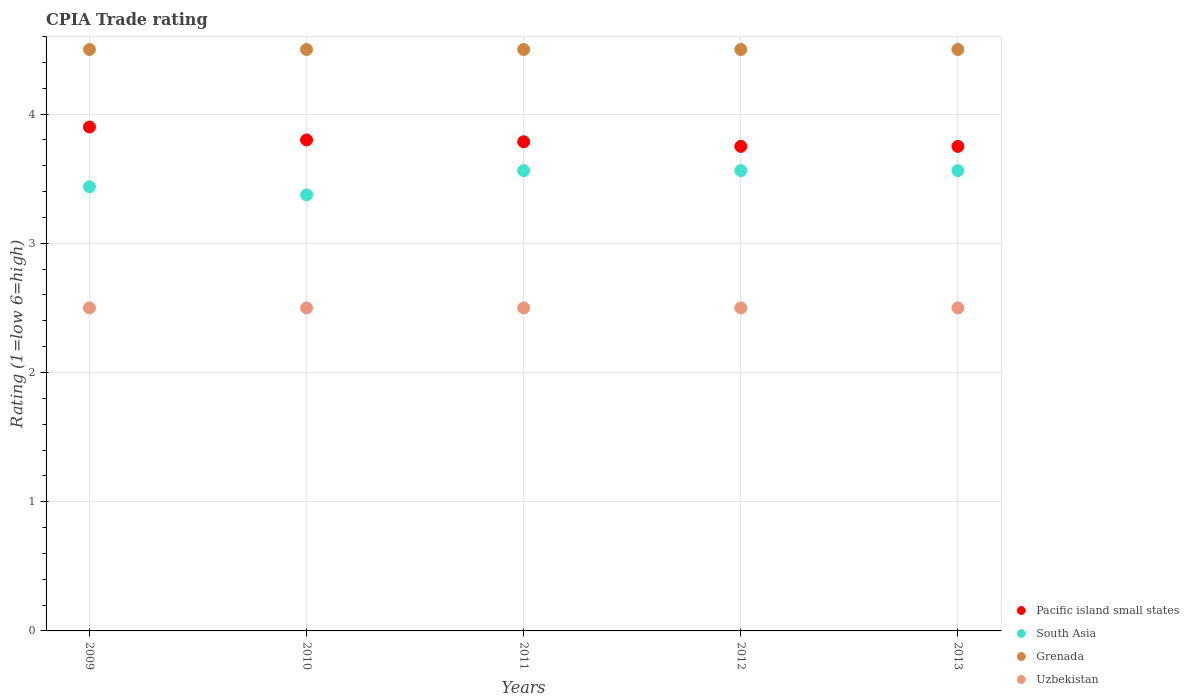Is the number of dotlines equal to the number of legend labels?
Your answer should be compact. Yes. What is the CPIA rating in Uzbekistan in 2011?
Offer a very short reply. 2.5. Across all years, what is the minimum CPIA rating in Pacific island small states?
Offer a terse response. 3.75. In which year was the CPIA rating in Uzbekistan maximum?
Your answer should be compact. 2009. What is the difference between the CPIA rating in Uzbekistan in 2009 and that in 2011?
Provide a short and direct response. 0. What is the difference between the CPIA rating in Pacific island small states in 2013 and the CPIA rating in South Asia in 2012?
Provide a short and direct response. 0.19. What is the average CPIA rating in Grenada per year?
Ensure brevity in your answer.  4.5. In the year 2013, what is the difference between the CPIA rating in Grenada and CPIA rating in South Asia?
Your response must be concise. 0.94. What is the ratio of the CPIA rating in South Asia in 2010 to that in 2011?
Keep it short and to the point. 0.95. Is the CPIA rating in Pacific island small states in 2009 less than that in 2010?
Your answer should be very brief. No. What is the difference between the highest and the second highest CPIA rating in Grenada?
Offer a terse response. 0. Is it the case that in every year, the sum of the CPIA rating in South Asia and CPIA rating in Grenada  is greater than the sum of CPIA rating in Uzbekistan and CPIA rating in Pacific island small states?
Your answer should be compact. Yes. Does the CPIA rating in Pacific island small states monotonically increase over the years?
Provide a succinct answer. No. How many dotlines are there?
Offer a very short reply. 4. How many years are there in the graph?
Ensure brevity in your answer.  5. Does the graph contain grids?
Your answer should be very brief. Yes. Where does the legend appear in the graph?
Provide a short and direct response. Bottom right. How many legend labels are there?
Your response must be concise. 4. What is the title of the graph?
Give a very brief answer. CPIA Trade rating. Does "East Asia (developing only)" appear as one of the legend labels in the graph?
Provide a succinct answer. No. What is the label or title of the X-axis?
Keep it short and to the point. Years. What is the label or title of the Y-axis?
Make the answer very short. Rating (1=low 6=high). What is the Rating (1=low 6=high) of South Asia in 2009?
Ensure brevity in your answer.  3.44. What is the Rating (1=low 6=high) of Grenada in 2009?
Keep it short and to the point. 4.5. What is the Rating (1=low 6=high) of Uzbekistan in 2009?
Make the answer very short. 2.5. What is the Rating (1=low 6=high) of South Asia in 2010?
Keep it short and to the point. 3.38. What is the Rating (1=low 6=high) in Grenada in 2010?
Your response must be concise. 4.5. What is the Rating (1=low 6=high) of Pacific island small states in 2011?
Offer a very short reply. 3.79. What is the Rating (1=low 6=high) in South Asia in 2011?
Provide a succinct answer. 3.56. What is the Rating (1=low 6=high) in Pacific island small states in 2012?
Your answer should be very brief. 3.75. What is the Rating (1=low 6=high) of South Asia in 2012?
Your answer should be very brief. 3.56. What is the Rating (1=low 6=high) of Grenada in 2012?
Your response must be concise. 4.5. What is the Rating (1=low 6=high) of Pacific island small states in 2013?
Your answer should be very brief. 3.75. What is the Rating (1=low 6=high) of South Asia in 2013?
Give a very brief answer. 3.56. What is the Rating (1=low 6=high) in Grenada in 2013?
Make the answer very short. 4.5. Across all years, what is the maximum Rating (1=low 6=high) of Pacific island small states?
Keep it short and to the point. 3.9. Across all years, what is the maximum Rating (1=low 6=high) of South Asia?
Your answer should be compact. 3.56. Across all years, what is the maximum Rating (1=low 6=high) of Uzbekistan?
Offer a very short reply. 2.5. Across all years, what is the minimum Rating (1=low 6=high) of Pacific island small states?
Keep it short and to the point. 3.75. Across all years, what is the minimum Rating (1=low 6=high) of South Asia?
Offer a very short reply. 3.38. Across all years, what is the minimum Rating (1=low 6=high) of Grenada?
Make the answer very short. 4.5. Across all years, what is the minimum Rating (1=low 6=high) in Uzbekistan?
Offer a very short reply. 2.5. What is the total Rating (1=low 6=high) in Pacific island small states in the graph?
Your response must be concise. 18.99. What is the total Rating (1=low 6=high) in South Asia in the graph?
Offer a terse response. 17.5. What is the total Rating (1=low 6=high) of Uzbekistan in the graph?
Provide a short and direct response. 12.5. What is the difference between the Rating (1=low 6=high) in Pacific island small states in 2009 and that in 2010?
Keep it short and to the point. 0.1. What is the difference between the Rating (1=low 6=high) of South Asia in 2009 and that in 2010?
Your response must be concise. 0.06. What is the difference between the Rating (1=low 6=high) in Uzbekistan in 2009 and that in 2010?
Your answer should be compact. 0. What is the difference between the Rating (1=low 6=high) in Pacific island small states in 2009 and that in 2011?
Your answer should be compact. 0.11. What is the difference between the Rating (1=low 6=high) of South Asia in 2009 and that in 2011?
Provide a short and direct response. -0.12. What is the difference between the Rating (1=low 6=high) of South Asia in 2009 and that in 2012?
Your answer should be compact. -0.12. What is the difference between the Rating (1=low 6=high) of Grenada in 2009 and that in 2012?
Offer a very short reply. 0. What is the difference between the Rating (1=low 6=high) in Uzbekistan in 2009 and that in 2012?
Offer a terse response. 0. What is the difference between the Rating (1=low 6=high) in South Asia in 2009 and that in 2013?
Make the answer very short. -0.12. What is the difference between the Rating (1=low 6=high) in Grenada in 2009 and that in 2013?
Your answer should be very brief. 0. What is the difference between the Rating (1=low 6=high) in Pacific island small states in 2010 and that in 2011?
Offer a very short reply. 0.01. What is the difference between the Rating (1=low 6=high) of South Asia in 2010 and that in 2011?
Give a very brief answer. -0.19. What is the difference between the Rating (1=low 6=high) of South Asia in 2010 and that in 2012?
Your answer should be very brief. -0.19. What is the difference between the Rating (1=low 6=high) in South Asia in 2010 and that in 2013?
Provide a succinct answer. -0.19. What is the difference between the Rating (1=low 6=high) in Grenada in 2010 and that in 2013?
Your answer should be very brief. 0. What is the difference between the Rating (1=low 6=high) in Uzbekistan in 2010 and that in 2013?
Give a very brief answer. 0. What is the difference between the Rating (1=low 6=high) of Pacific island small states in 2011 and that in 2012?
Provide a succinct answer. 0.04. What is the difference between the Rating (1=low 6=high) in Pacific island small states in 2011 and that in 2013?
Keep it short and to the point. 0.04. What is the difference between the Rating (1=low 6=high) of Grenada in 2011 and that in 2013?
Offer a very short reply. 0. What is the difference between the Rating (1=low 6=high) of Pacific island small states in 2012 and that in 2013?
Keep it short and to the point. 0. What is the difference between the Rating (1=low 6=high) in Uzbekistan in 2012 and that in 2013?
Keep it short and to the point. 0. What is the difference between the Rating (1=low 6=high) in Pacific island small states in 2009 and the Rating (1=low 6=high) in South Asia in 2010?
Your response must be concise. 0.53. What is the difference between the Rating (1=low 6=high) in Pacific island small states in 2009 and the Rating (1=low 6=high) in Grenada in 2010?
Provide a succinct answer. -0.6. What is the difference between the Rating (1=low 6=high) in South Asia in 2009 and the Rating (1=low 6=high) in Grenada in 2010?
Offer a very short reply. -1.06. What is the difference between the Rating (1=low 6=high) of South Asia in 2009 and the Rating (1=low 6=high) of Uzbekistan in 2010?
Ensure brevity in your answer.  0.94. What is the difference between the Rating (1=low 6=high) in Pacific island small states in 2009 and the Rating (1=low 6=high) in South Asia in 2011?
Your answer should be compact. 0.34. What is the difference between the Rating (1=low 6=high) in Pacific island small states in 2009 and the Rating (1=low 6=high) in Grenada in 2011?
Offer a terse response. -0.6. What is the difference between the Rating (1=low 6=high) in South Asia in 2009 and the Rating (1=low 6=high) in Grenada in 2011?
Make the answer very short. -1.06. What is the difference between the Rating (1=low 6=high) in South Asia in 2009 and the Rating (1=low 6=high) in Uzbekistan in 2011?
Your answer should be compact. 0.94. What is the difference between the Rating (1=low 6=high) of Grenada in 2009 and the Rating (1=low 6=high) of Uzbekistan in 2011?
Offer a terse response. 2. What is the difference between the Rating (1=low 6=high) in Pacific island small states in 2009 and the Rating (1=low 6=high) in South Asia in 2012?
Your response must be concise. 0.34. What is the difference between the Rating (1=low 6=high) in Pacific island small states in 2009 and the Rating (1=low 6=high) in Grenada in 2012?
Provide a short and direct response. -0.6. What is the difference between the Rating (1=low 6=high) of Pacific island small states in 2009 and the Rating (1=low 6=high) of Uzbekistan in 2012?
Offer a very short reply. 1.4. What is the difference between the Rating (1=low 6=high) in South Asia in 2009 and the Rating (1=low 6=high) in Grenada in 2012?
Your response must be concise. -1.06. What is the difference between the Rating (1=low 6=high) of Pacific island small states in 2009 and the Rating (1=low 6=high) of South Asia in 2013?
Ensure brevity in your answer.  0.34. What is the difference between the Rating (1=low 6=high) of Pacific island small states in 2009 and the Rating (1=low 6=high) of Uzbekistan in 2013?
Your response must be concise. 1.4. What is the difference between the Rating (1=low 6=high) of South Asia in 2009 and the Rating (1=low 6=high) of Grenada in 2013?
Ensure brevity in your answer.  -1.06. What is the difference between the Rating (1=low 6=high) of Grenada in 2009 and the Rating (1=low 6=high) of Uzbekistan in 2013?
Your response must be concise. 2. What is the difference between the Rating (1=low 6=high) of Pacific island small states in 2010 and the Rating (1=low 6=high) of South Asia in 2011?
Keep it short and to the point. 0.24. What is the difference between the Rating (1=low 6=high) of Pacific island small states in 2010 and the Rating (1=low 6=high) of Uzbekistan in 2011?
Offer a very short reply. 1.3. What is the difference between the Rating (1=low 6=high) of South Asia in 2010 and the Rating (1=low 6=high) of Grenada in 2011?
Provide a succinct answer. -1.12. What is the difference between the Rating (1=low 6=high) in Pacific island small states in 2010 and the Rating (1=low 6=high) in South Asia in 2012?
Ensure brevity in your answer.  0.24. What is the difference between the Rating (1=low 6=high) in Pacific island small states in 2010 and the Rating (1=low 6=high) in Grenada in 2012?
Your response must be concise. -0.7. What is the difference between the Rating (1=low 6=high) in Pacific island small states in 2010 and the Rating (1=low 6=high) in Uzbekistan in 2012?
Give a very brief answer. 1.3. What is the difference between the Rating (1=low 6=high) in South Asia in 2010 and the Rating (1=low 6=high) in Grenada in 2012?
Your answer should be very brief. -1.12. What is the difference between the Rating (1=low 6=high) of South Asia in 2010 and the Rating (1=low 6=high) of Uzbekistan in 2012?
Your answer should be compact. 0.88. What is the difference between the Rating (1=low 6=high) in Pacific island small states in 2010 and the Rating (1=low 6=high) in South Asia in 2013?
Ensure brevity in your answer.  0.24. What is the difference between the Rating (1=low 6=high) in Pacific island small states in 2010 and the Rating (1=low 6=high) in Grenada in 2013?
Provide a short and direct response. -0.7. What is the difference between the Rating (1=low 6=high) in Pacific island small states in 2010 and the Rating (1=low 6=high) in Uzbekistan in 2013?
Your answer should be very brief. 1.3. What is the difference between the Rating (1=low 6=high) in South Asia in 2010 and the Rating (1=low 6=high) in Grenada in 2013?
Your answer should be compact. -1.12. What is the difference between the Rating (1=low 6=high) in South Asia in 2010 and the Rating (1=low 6=high) in Uzbekistan in 2013?
Make the answer very short. 0.88. What is the difference between the Rating (1=low 6=high) in Grenada in 2010 and the Rating (1=low 6=high) in Uzbekistan in 2013?
Keep it short and to the point. 2. What is the difference between the Rating (1=low 6=high) in Pacific island small states in 2011 and the Rating (1=low 6=high) in South Asia in 2012?
Your answer should be compact. 0.22. What is the difference between the Rating (1=low 6=high) of Pacific island small states in 2011 and the Rating (1=low 6=high) of Grenada in 2012?
Offer a very short reply. -0.71. What is the difference between the Rating (1=low 6=high) of Pacific island small states in 2011 and the Rating (1=low 6=high) of Uzbekistan in 2012?
Provide a short and direct response. 1.29. What is the difference between the Rating (1=low 6=high) of South Asia in 2011 and the Rating (1=low 6=high) of Grenada in 2012?
Keep it short and to the point. -0.94. What is the difference between the Rating (1=low 6=high) of Pacific island small states in 2011 and the Rating (1=low 6=high) of South Asia in 2013?
Offer a terse response. 0.22. What is the difference between the Rating (1=low 6=high) in Pacific island small states in 2011 and the Rating (1=low 6=high) in Grenada in 2013?
Offer a very short reply. -0.71. What is the difference between the Rating (1=low 6=high) in South Asia in 2011 and the Rating (1=low 6=high) in Grenada in 2013?
Offer a very short reply. -0.94. What is the difference between the Rating (1=low 6=high) in Pacific island small states in 2012 and the Rating (1=low 6=high) in South Asia in 2013?
Offer a very short reply. 0.19. What is the difference between the Rating (1=low 6=high) in Pacific island small states in 2012 and the Rating (1=low 6=high) in Grenada in 2013?
Offer a terse response. -0.75. What is the difference between the Rating (1=low 6=high) in South Asia in 2012 and the Rating (1=low 6=high) in Grenada in 2013?
Your answer should be very brief. -0.94. What is the difference between the Rating (1=low 6=high) of South Asia in 2012 and the Rating (1=low 6=high) of Uzbekistan in 2013?
Give a very brief answer. 1.06. What is the difference between the Rating (1=low 6=high) in Grenada in 2012 and the Rating (1=low 6=high) in Uzbekistan in 2013?
Keep it short and to the point. 2. What is the average Rating (1=low 6=high) of Pacific island small states per year?
Ensure brevity in your answer.  3.8. What is the average Rating (1=low 6=high) in Grenada per year?
Your response must be concise. 4.5. In the year 2009, what is the difference between the Rating (1=low 6=high) of Pacific island small states and Rating (1=low 6=high) of South Asia?
Make the answer very short. 0.46. In the year 2009, what is the difference between the Rating (1=low 6=high) of Pacific island small states and Rating (1=low 6=high) of Uzbekistan?
Give a very brief answer. 1.4. In the year 2009, what is the difference between the Rating (1=low 6=high) of South Asia and Rating (1=low 6=high) of Grenada?
Ensure brevity in your answer.  -1.06. In the year 2009, what is the difference between the Rating (1=low 6=high) in Grenada and Rating (1=low 6=high) in Uzbekistan?
Offer a very short reply. 2. In the year 2010, what is the difference between the Rating (1=low 6=high) in Pacific island small states and Rating (1=low 6=high) in South Asia?
Make the answer very short. 0.42. In the year 2010, what is the difference between the Rating (1=low 6=high) of Pacific island small states and Rating (1=low 6=high) of Uzbekistan?
Provide a succinct answer. 1.3. In the year 2010, what is the difference between the Rating (1=low 6=high) in South Asia and Rating (1=low 6=high) in Grenada?
Your response must be concise. -1.12. In the year 2010, what is the difference between the Rating (1=low 6=high) in Grenada and Rating (1=low 6=high) in Uzbekistan?
Make the answer very short. 2. In the year 2011, what is the difference between the Rating (1=low 6=high) of Pacific island small states and Rating (1=low 6=high) of South Asia?
Offer a terse response. 0.22. In the year 2011, what is the difference between the Rating (1=low 6=high) of Pacific island small states and Rating (1=low 6=high) of Grenada?
Offer a very short reply. -0.71. In the year 2011, what is the difference between the Rating (1=low 6=high) of South Asia and Rating (1=low 6=high) of Grenada?
Your answer should be compact. -0.94. In the year 2011, what is the difference between the Rating (1=low 6=high) in South Asia and Rating (1=low 6=high) in Uzbekistan?
Give a very brief answer. 1.06. In the year 2011, what is the difference between the Rating (1=low 6=high) in Grenada and Rating (1=low 6=high) in Uzbekistan?
Provide a succinct answer. 2. In the year 2012, what is the difference between the Rating (1=low 6=high) in Pacific island small states and Rating (1=low 6=high) in South Asia?
Give a very brief answer. 0.19. In the year 2012, what is the difference between the Rating (1=low 6=high) of Pacific island small states and Rating (1=low 6=high) of Grenada?
Give a very brief answer. -0.75. In the year 2012, what is the difference between the Rating (1=low 6=high) in South Asia and Rating (1=low 6=high) in Grenada?
Ensure brevity in your answer.  -0.94. In the year 2013, what is the difference between the Rating (1=low 6=high) in Pacific island small states and Rating (1=low 6=high) in South Asia?
Keep it short and to the point. 0.19. In the year 2013, what is the difference between the Rating (1=low 6=high) in Pacific island small states and Rating (1=low 6=high) in Grenada?
Give a very brief answer. -0.75. In the year 2013, what is the difference between the Rating (1=low 6=high) in South Asia and Rating (1=low 6=high) in Grenada?
Make the answer very short. -0.94. In the year 2013, what is the difference between the Rating (1=low 6=high) in South Asia and Rating (1=low 6=high) in Uzbekistan?
Offer a terse response. 1.06. In the year 2013, what is the difference between the Rating (1=low 6=high) of Grenada and Rating (1=low 6=high) of Uzbekistan?
Provide a succinct answer. 2. What is the ratio of the Rating (1=low 6=high) of Pacific island small states in 2009 to that in 2010?
Provide a short and direct response. 1.03. What is the ratio of the Rating (1=low 6=high) in South Asia in 2009 to that in 2010?
Make the answer very short. 1.02. What is the ratio of the Rating (1=low 6=high) of Grenada in 2009 to that in 2010?
Your answer should be very brief. 1. What is the ratio of the Rating (1=low 6=high) of Uzbekistan in 2009 to that in 2010?
Offer a terse response. 1. What is the ratio of the Rating (1=low 6=high) of Pacific island small states in 2009 to that in 2011?
Offer a very short reply. 1.03. What is the ratio of the Rating (1=low 6=high) in South Asia in 2009 to that in 2011?
Offer a very short reply. 0.96. What is the ratio of the Rating (1=low 6=high) of Uzbekistan in 2009 to that in 2011?
Your response must be concise. 1. What is the ratio of the Rating (1=low 6=high) of South Asia in 2009 to that in 2012?
Your answer should be very brief. 0.96. What is the ratio of the Rating (1=low 6=high) in Uzbekistan in 2009 to that in 2012?
Make the answer very short. 1. What is the ratio of the Rating (1=low 6=high) of South Asia in 2009 to that in 2013?
Provide a short and direct response. 0.96. What is the ratio of the Rating (1=low 6=high) in Grenada in 2009 to that in 2013?
Keep it short and to the point. 1. What is the ratio of the Rating (1=low 6=high) in Uzbekistan in 2009 to that in 2013?
Provide a short and direct response. 1. What is the ratio of the Rating (1=low 6=high) of Pacific island small states in 2010 to that in 2011?
Keep it short and to the point. 1. What is the ratio of the Rating (1=low 6=high) of Pacific island small states in 2010 to that in 2012?
Provide a succinct answer. 1.01. What is the ratio of the Rating (1=low 6=high) in South Asia in 2010 to that in 2012?
Keep it short and to the point. 0.95. What is the ratio of the Rating (1=low 6=high) of Grenada in 2010 to that in 2012?
Your response must be concise. 1. What is the ratio of the Rating (1=low 6=high) of Pacific island small states in 2010 to that in 2013?
Make the answer very short. 1.01. What is the ratio of the Rating (1=low 6=high) in South Asia in 2010 to that in 2013?
Provide a succinct answer. 0.95. What is the ratio of the Rating (1=low 6=high) in Grenada in 2010 to that in 2013?
Offer a very short reply. 1. What is the ratio of the Rating (1=low 6=high) of Uzbekistan in 2010 to that in 2013?
Ensure brevity in your answer.  1. What is the ratio of the Rating (1=low 6=high) in Pacific island small states in 2011 to that in 2012?
Your answer should be compact. 1.01. What is the ratio of the Rating (1=low 6=high) of South Asia in 2011 to that in 2012?
Ensure brevity in your answer.  1. What is the ratio of the Rating (1=low 6=high) in Uzbekistan in 2011 to that in 2012?
Your response must be concise. 1. What is the ratio of the Rating (1=low 6=high) of Pacific island small states in 2011 to that in 2013?
Make the answer very short. 1.01. What is the ratio of the Rating (1=low 6=high) of South Asia in 2011 to that in 2013?
Offer a very short reply. 1. What is the ratio of the Rating (1=low 6=high) in Pacific island small states in 2012 to that in 2013?
Provide a succinct answer. 1. What is the ratio of the Rating (1=low 6=high) of South Asia in 2012 to that in 2013?
Ensure brevity in your answer.  1. What is the ratio of the Rating (1=low 6=high) in Grenada in 2012 to that in 2013?
Provide a succinct answer. 1. What is the ratio of the Rating (1=low 6=high) of Uzbekistan in 2012 to that in 2013?
Make the answer very short. 1. What is the difference between the highest and the second highest Rating (1=low 6=high) in Pacific island small states?
Ensure brevity in your answer.  0.1. What is the difference between the highest and the lowest Rating (1=low 6=high) of Pacific island small states?
Provide a succinct answer. 0.15. What is the difference between the highest and the lowest Rating (1=low 6=high) in South Asia?
Offer a terse response. 0.19. What is the difference between the highest and the lowest Rating (1=low 6=high) in Grenada?
Make the answer very short. 0. 